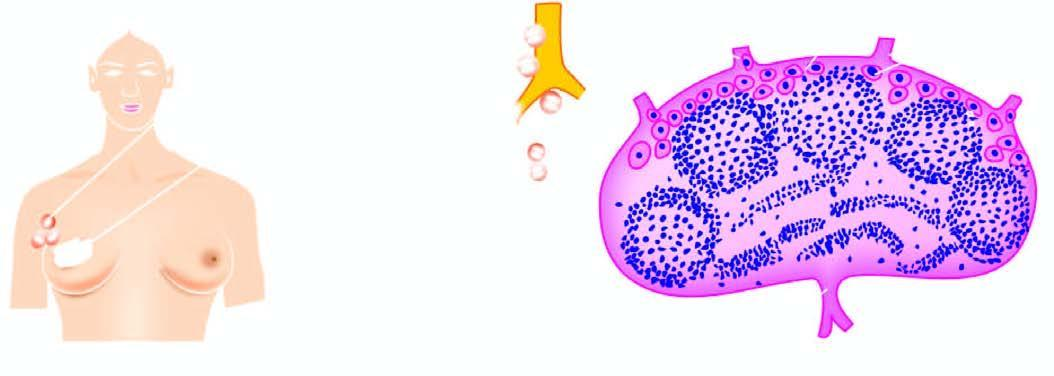does uppurative diseases begin by lodgement of tumour cells in subcapsular sinus via afferent lymphatics entering at the convex surface of the lymph node?
Answer the question using a single word or phrase. No 